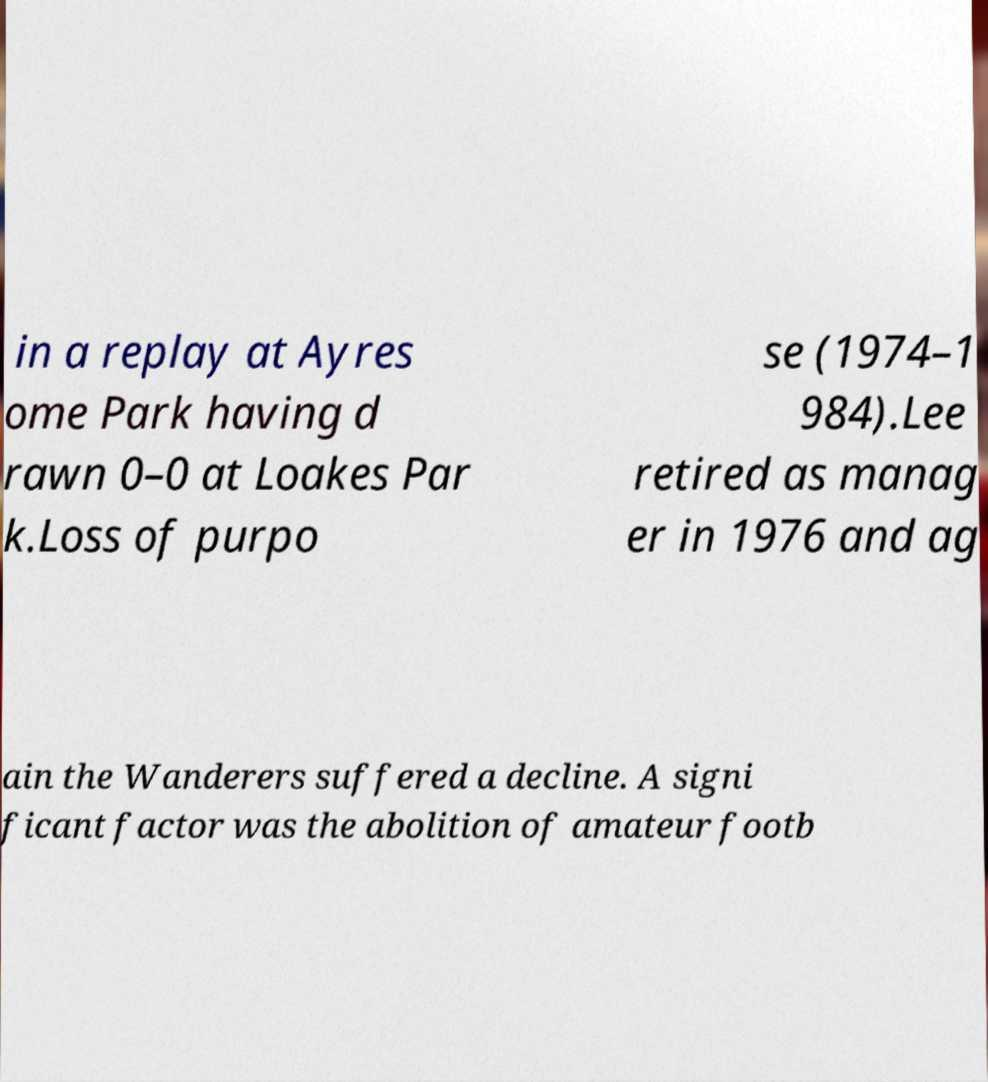There's text embedded in this image that I need extracted. Can you transcribe it verbatim? in a replay at Ayres ome Park having d rawn 0–0 at Loakes Par k.Loss of purpo se (1974–1 984).Lee retired as manag er in 1976 and ag ain the Wanderers suffered a decline. A signi ficant factor was the abolition of amateur footb 